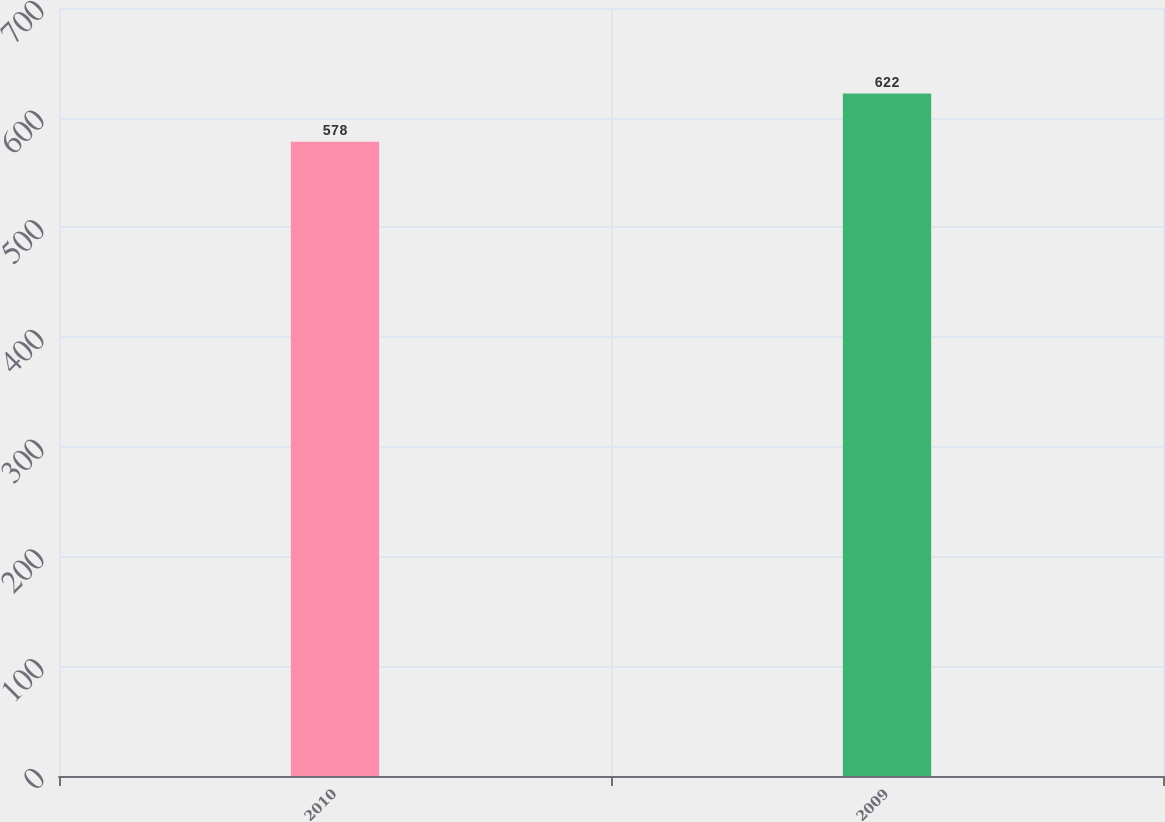<chart> <loc_0><loc_0><loc_500><loc_500><bar_chart><fcel>2010<fcel>2009<nl><fcel>578<fcel>622<nl></chart> 